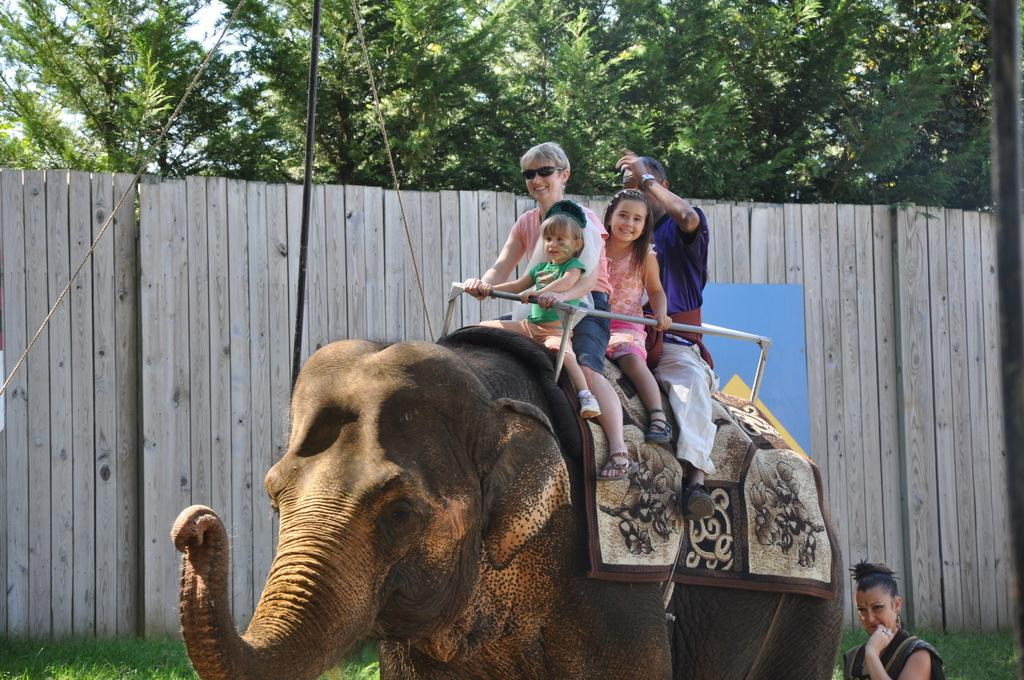How many people are in the image? There are four people in the image: a woman, a man, and two kids. What are the people in the image doing? The woman, man, and kids are riding on an elephant. Who is beside the elephant on the right side? There is a woman beside the elephant on the right side. What can be seen in the background of the image? In the background of the image, there is a fence, a rope, a pole, and trees. What type of punishment is being administered to the boy in the image? There is no boy present in the image, and therefore no punishment can be observed. What color is the hydrant in the image? There is no hydrant present in the image. 